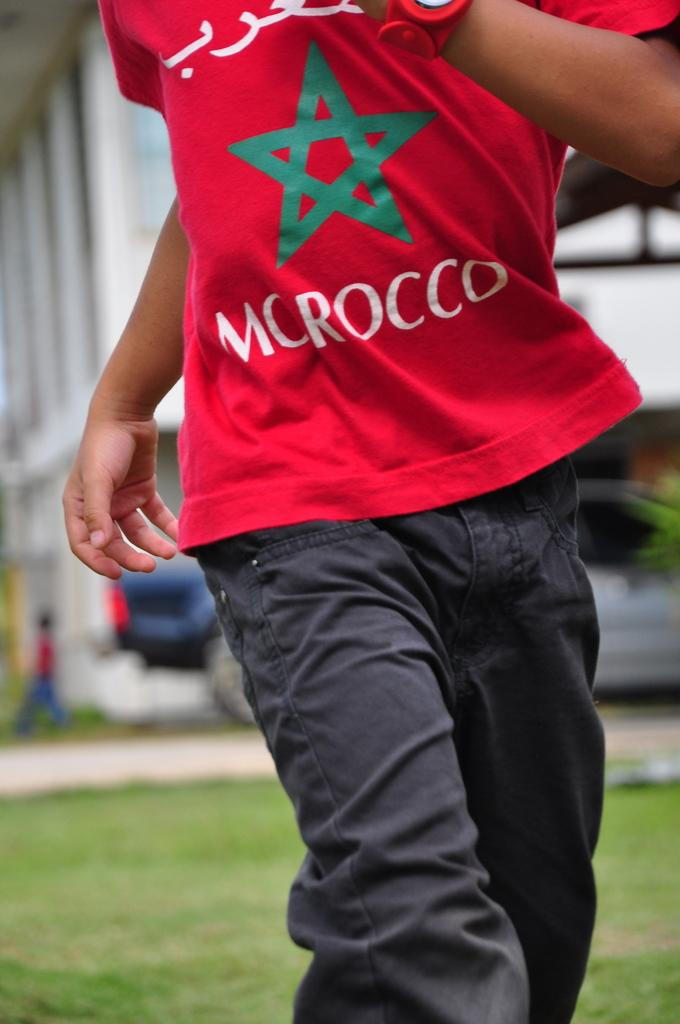<image>
Describe the image concisely. someone in a red shirt with the moroccon colors running 